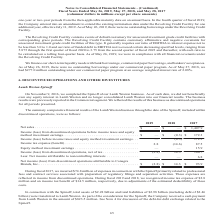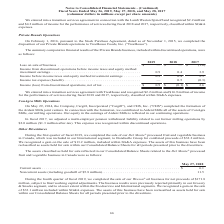According to Conagra Brands's financial document, What did expenses in connection with the Spinoff primarily relate to in the fiscal year 2017? professional fees and contract services associated with preparation of regulatory filings and separation activities. The document states: "connection with the Spinoff primarily related to professional fees and contract services associated with preparation of regulatory filings and separat..." Also, How many assets and liabilities concerning the Spinoff were transferred to Lamb Weston respectively? The document shows two values: $2.28 billion and $2.98 billion. From the document: "In connection with the Spinoff, total assets of $2.28 billion and total liabilities of $2.98 billion (including debt of $2.46 l assets of $2.28 billio..." Also, What was the net sales (in millions) in 2017? According to the financial document, $1,407.9. The relevant text states: "Net sales . $ — $ — $ 1,407.9..." Also, can you calculate: What is the net profit margin in 2017? Based on the calculation: 93.9/1,407.9 , the result is 0.07. This is based on the information: "Net sales . $ — $ — $ 1,407.9 table to Conagra Brands, Inc.. . $ (2.8) $ 14.3 $ 93.9..." The key data points involved are: 1,407.9, 93.9. Also, can you calculate: What is the percentage change in net income (loss) from discontinued operations attributable to Conagra Brands, Inc. from 2017 to 2018? To answer this question, I need to perform calculations using the financial data. The calculation is: (14.3-93.9)/93.9 , which equals -84.77 (percentage). This is based on the information: "from discontinued operations, net of tax . (2.8) 14.3 100.7 table to Conagra Brands, Inc.. . $ (2.8) $ 14.3 $ 93.9..." The key data points involved are: 14.3, 93.9. Also, can you calculate: What is the proportion (in percentage) of income tax benefit due to adjustment of the estimated deductibility of professional fees and contract services over income tax benefit in 2018? Based on the calculation: 14.5/14.6 , the result is 99.32 (percentage). This is based on the information: "Income tax expense (benefit) . 2.8 (14.6) 87.5 nse of $2.8 million and an income tax benefit of $14.5 million, respectively, due to adjustments of the estimated deductibility of these costs...." The key data points involved are: 14.5, 14.6. 